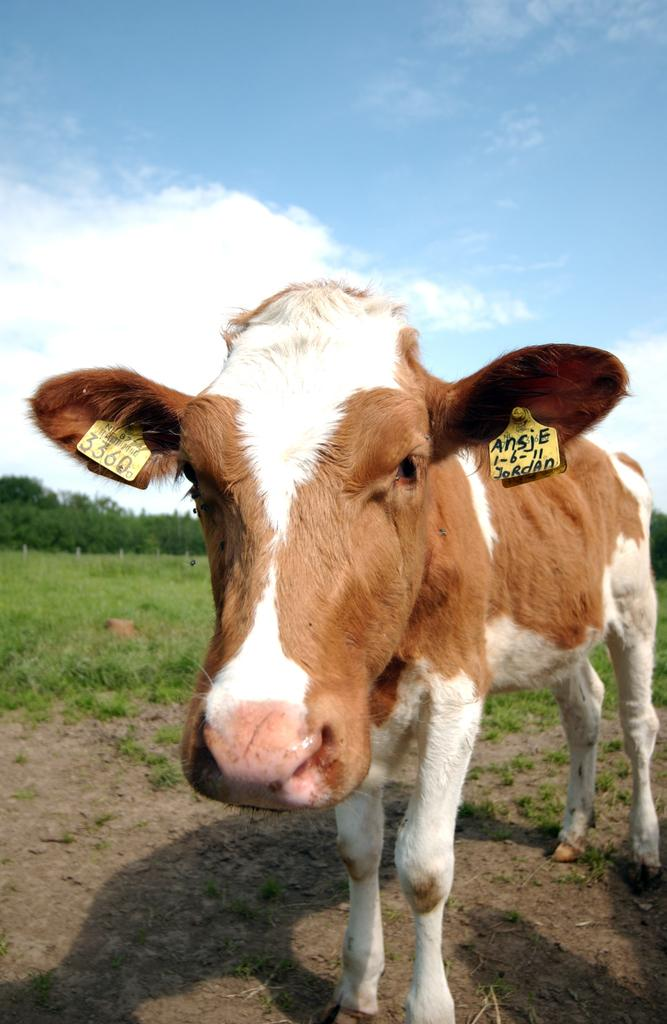What animal is present in the image? There is a cow in the image. Can you describe the cow's appearance? The cow has a white and brown color. Where is the cow located in the image? The cow is standing in the ground. What is the cow doing in the image? The cow is looking at the camera. What can be seen in the background of the image? The sky is visible in the image, and clouds are present in the sky. Where is the nearest tin store located in the image? There is no tin store present in the image. What type of downtown area can be seen in the image? There is no downtown area present in the image; it features a cow standing in the ground with a sky background. 